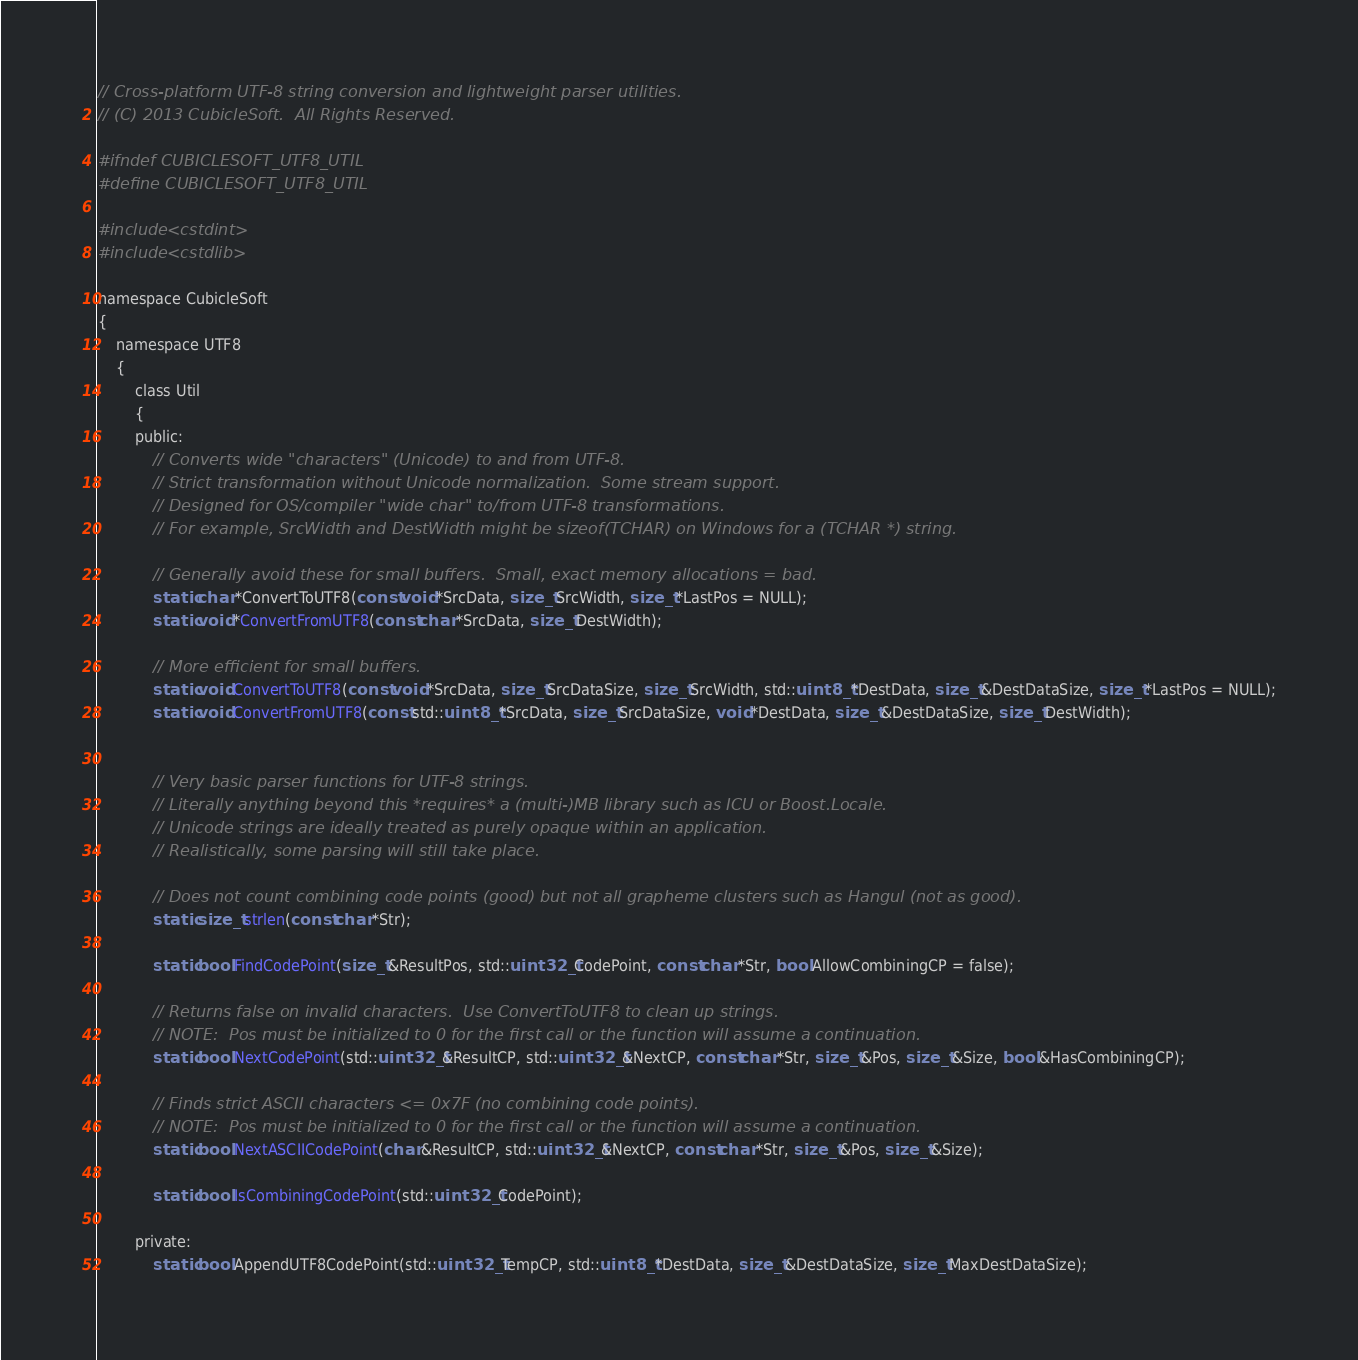Convert code to text. <code><loc_0><loc_0><loc_500><loc_500><_C_>// Cross-platform UTF-8 string conversion and lightweight parser utilities.
// (C) 2013 CubicleSoft.  All Rights Reserved.

#ifndef CUBICLESOFT_UTF8_UTIL
#define CUBICLESOFT_UTF8_UTIL

#include <cstdint>
#include <cstdlib>

namespace CubicleSoft
{
	namespace UTF8
	{
		class Util
		{
		public:
			// Converts wide "characters" (Unicode) to and from UTF-8.
			// Strict transformation without Unicode normalization.  Some stream support.
			// Designed for OS/compiler "wide char" to/from UTF-8 transformations.
			// For example, SrcWidth and DestWidth might be sizeof(TCHAR) on Windows for a (TCHAR *) string.

			// Generally avoid these for small buffers.  Small, exact memory allocations = bad.
			static char *ConvertToUTF8(const void *SrcData, size_t SrcWidth, size_t *LastPos = NULL);
			static void *ConvertFromUTF8(const char *SrcData, size_t DestWidth);

			// More efficient for small buffers.
			static void ConvertToUTF8(const void *SrcData, size_t SrcDataSize, size_t SrcWidth, std::uint8_t *DestData, size_t &DestDataSize, size_t *LastPos = NULL);
			static void ConvertFromUTF8(const std::uint8_t *SrcData, size_t SrcDataSize, void *DestData, size_t &DestDataSize, size_t DestWidth);


			// Very basic parser functions for UTF-8 strings.
			// Literally anything beyond this *requires* a (multi-)MB library such as ICU or Boost.Locale.
			// Unicode strings are ideally treated as purely opaque within an application.
			// Realistically, some parsing will still take place.

			// Does not count combining code points (good) but not all grapheme clusters such as Hangul (not as good).
			static size_t strlen(const char *Str);

			static bool FindCodePoint(size_t &ResultPos, std::uint32_t CodePoint, const char *Str, bool AllowCombiningCP = false);

			// Returns false on invalid characters.  Use ConvertToUTF8 to clean up strings.
			// NOTE:  Pos must be initialized to 0 for the first call or the function will assume a continuation.
			static bool NextCodePoint(std::uint32_t &ResultCP, std::uint32_t &NextCP, const char *Str, size_t &Pos, size_t &Size, bool &HasCombiningCP);

			// Finds strict ASCII characters <= 0x7F (no combining code points).
			// NOTE:  Pos must be initialized to 0 for the first call or the function will assume a continuation.
			static bool NextASCIICodePoint(char &ResultCP, std::uint32_t &NextCP, const char *Str, size_t &Pos, size_t &Size);

			static bool IsCombiningCodePoint(std::uint32_t CodePoint);

		private:
			static bool AppendUTF8CodePoint(std::uint32_t TempCP, std::uint8_t *DestData, size_t &DestDataSize, size_t MaxDestDataSize);</code> 